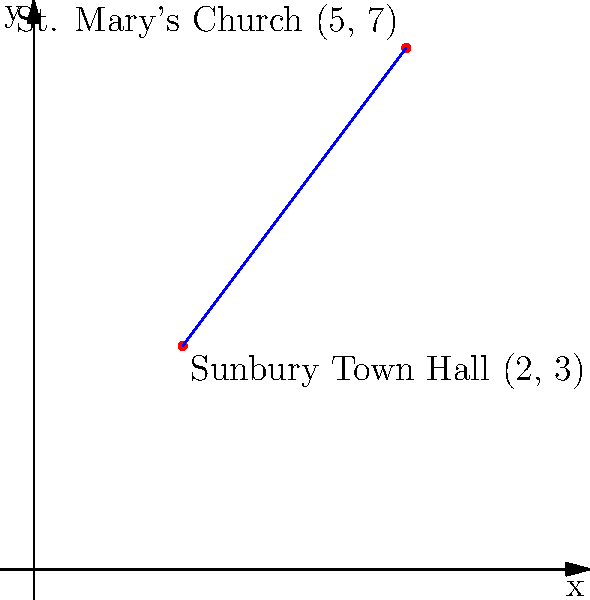In Sunbury, two historic landmarks are represented on a coordinate plane: the Sunbury Town Hall at (2, 3) and St. Mary's Church at (5, 7). Find the equation of the line that passes through these two points in slope-intercept form $(y = mx + b)$. To find the equation of the line passing through two points, we'll follow these steps:

1) First, calculate the slope $(m)$ using the slope formula:
   $m = \frac{y_2 - y_1}{x_2 - x_1}$

   Where $(x_1, y_1)$ is (2, 3) and $(x_2, y_2)$ is (5, 7)

   $m = \frac{7 - 3}{5 - 2} = \frac{4}{3} \approx 1.33$

2) Now that we have the slope, we can use the point-slope form of a line:
   $y - y_1 = m(x - x_1)$

   Let's use the Town Hall point (2, 3):
   $y - 3 = \frac{4}{3}(x - 2)$

3) Expand the equation:
   $y - 3 = \frac{4}{3}x - \frac{8}{3}$

4) Add 3 to both sides to isolate $y$:
   $y = \frac{4}{3}x - \frac{8}{3} + 3$

5) Simplify:
   $y = \frac{4}{3}x + \frac{1}{3}$

This is the equation of the line in slope-intercept form $(y = mx + b)$, where $m = \frac{4}{3}$ and $b = \frac{1}{3}$.
Answer: $y = \frac{4}{3}x + \frac{1}{3}$ 